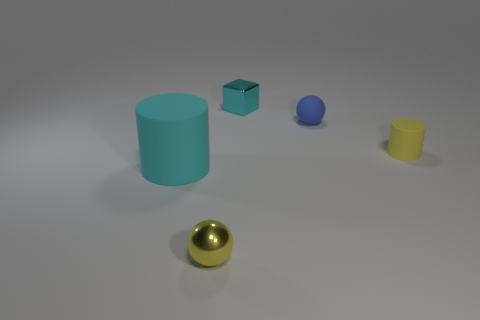Add 4 big blue matte things. How many objects exist? 9 Subtract all balls. How many objects are left? 3 Subtract all cyan rubber things. Subtract all blue balls. How many objects are left? 3 Add 3 tiny yellow rubber things. How many tiny yellow rubber things are left? 4 Add 5 blocks. How many blocks exist? 6 Subtract 0 green cylinders. How many objects are left? 5 